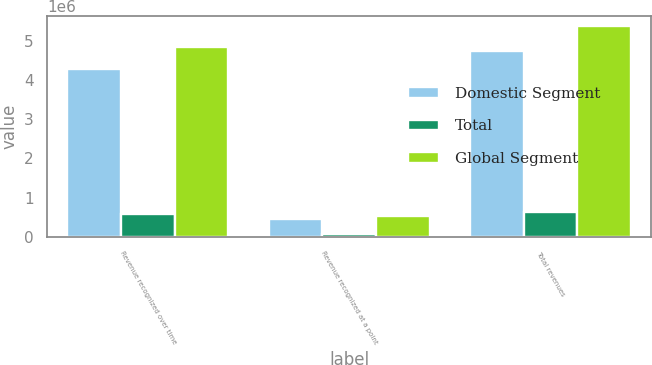<chart> <loc_0><loc_0><loc_500><loc_500><stacked_bar_chart><ecel><fcel>Revenue recognized over time<fcel>Revenue recognized at a point<fcel>Total revenues<nl><fcel>Domestic Segment<fcel>4.27193e+06<fcel>458332<fcel>4.73027e+06<nl><fcel>Total<fcel>569780<fcel>66279<fcel>636059<nl><fcel>Global Segment<fcel>4.84171e+06<fcel>524611<fcel>5.36632e+06<nl></chart> 